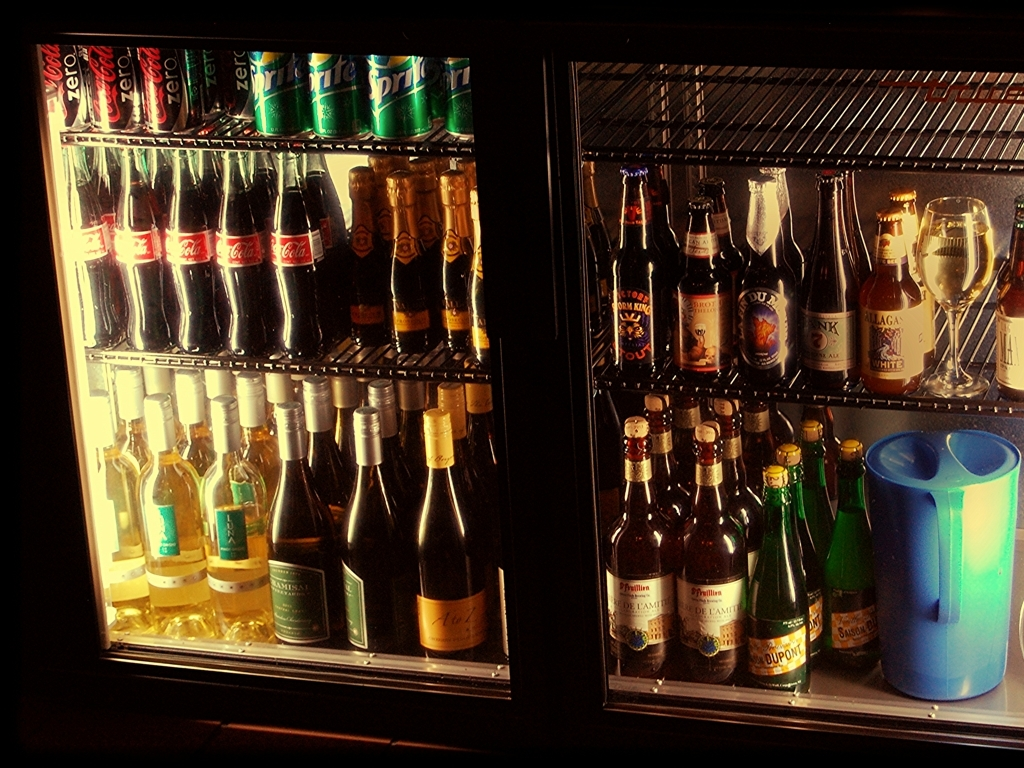Can you describe the types of beverages present in this image? The image prominently displays a selection of various beverages, including soft drinks like Coca-Cola and Sprite, bottled beers from different brands, as well as an assortment of white wines, all arranged inside a refrigerator with glass doors. What does the assortment of beverages suggest about the venue this refrigerator is in? The varied selection of alcoholic and non-alcoholic beverages suggests that the refrigerator could be located in a bar, restaurant, or perhaps a hotel minibar where guests are offered an array of drink choices to cater to diverse preferences. 